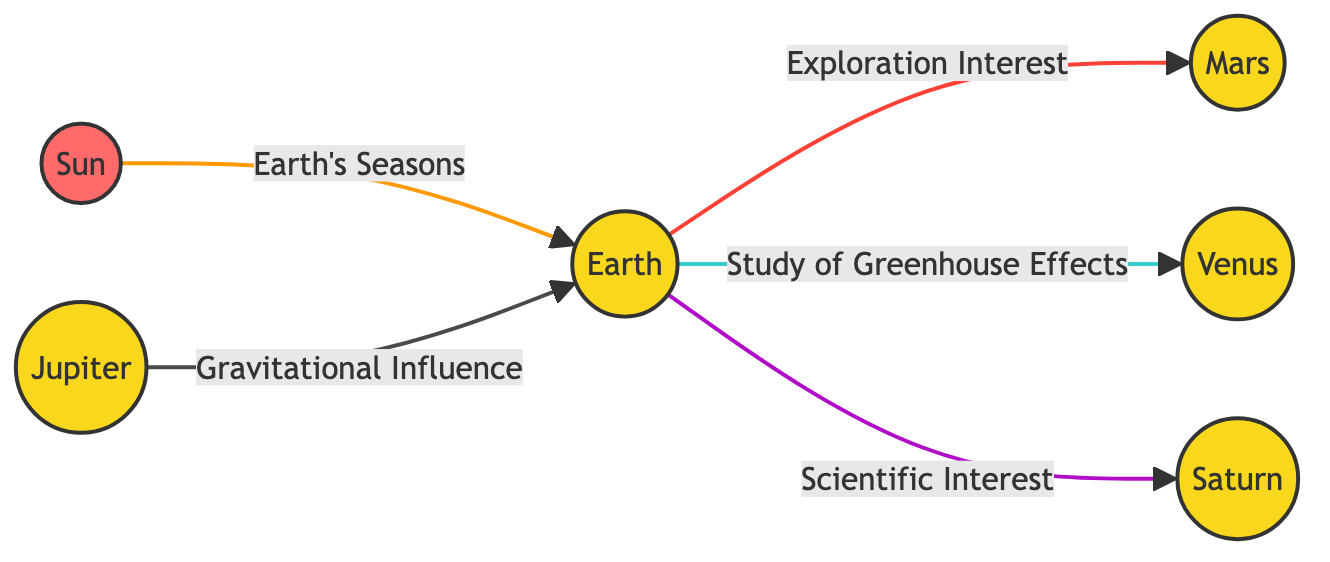What is the primary factor influencing Earth's seasons? The diagram shows that the Sun has a direct link to Earth regarding its seasons, indicating that the primary factor influencing Earth's seasons is the Sun.
Answer: Sun How many planets are shown in the diagram? The diagram includes six nodes that represent celestial bodies: Sun, Earth, Jupiter, Mars, Venus, and Saturn. Counting each one gives us the total number of planets represented.
Answer: 5 Which planet is linked to Earth's exploration interest? The diagram indicates that Earth has a direct link to Mars, emphasizing that Mars is the planet related to exploration interest.
Answer: Mars What type of influence does Jupiter have on Earth? In the diagram, Jupiter is described as having a "Gravitational Influence" on Earth. This specifies the nature of the connection between Jupiter and Earth.
Answer: Gravitational Influence Which planet is associated with the study of greenhouse effects? The diagram flows from Earth to Venus, which is identified as the planet linked to the study of greenhouse effects, indicating its importance in climate studies.
Answer: Venus What color represents the Sun in the diagram? The diagram assigns the Sun a distinctive color fill of bright red (#ff6b6b), which helps to differentiate it visually from the other celestial bodies.
Answer: Red What relationship does Saturn have with Earth? According to the diagram, Earth has a link to Saturn labeled "Scientific Interest," highlighting Saturn's significance in scientific exploration or study.
Answer: Scientific Interest Which planet shows a gravitational influence on Earth among those listed? The diagram explicitly connects Jupiter to Earth through the label "Gravitational Influence." This reveals Jupiter's role in affecting Earth's gravitational context.
Answer: Jupiter How many total connections are present in the diagram? By analyzing the diagram, we can count a total of five connections leading from and to various celestial bodies, highlighting the interrelated nature of the solar system as depicted here.
Answer: 5 